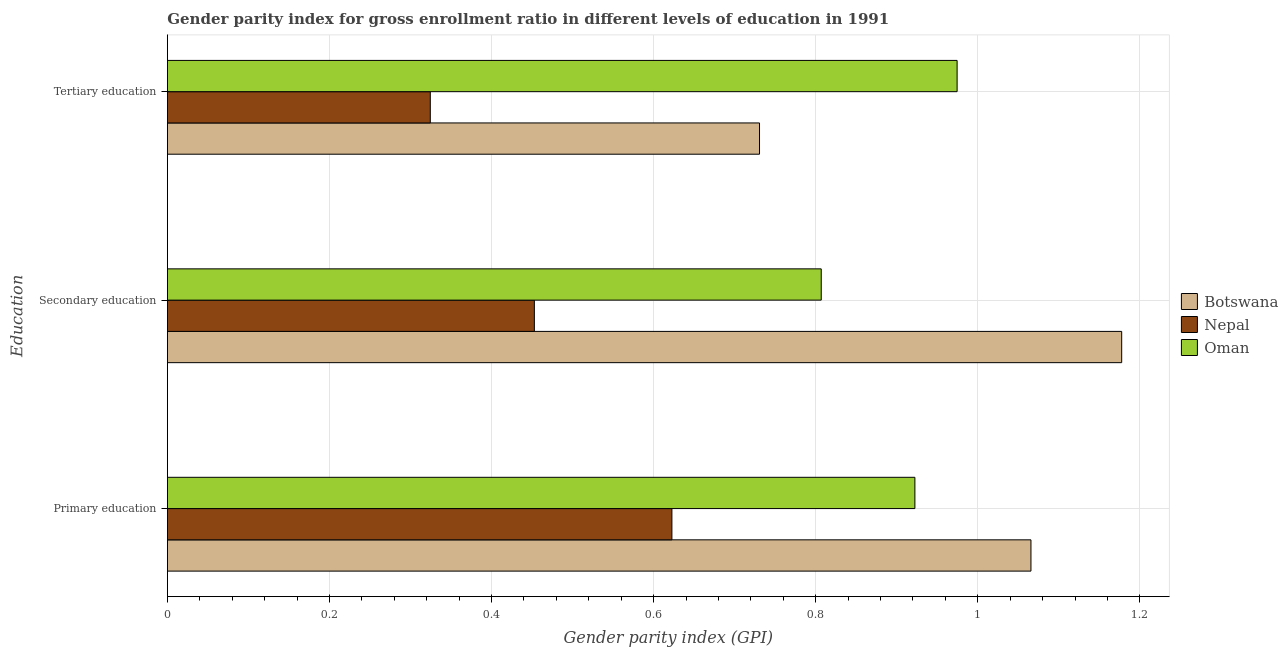Are the number of bars on each tick of the Y-axis equal?
Make the answer very short. Yes. How many bars are there on the 3rd tick from the top?
Ensure brevity in your answer.  3. How many bars are there on the 2nd tick from the bottom?
Provide a short and direct response. 3. What is the label of the 2nd group of bars from the top?
Your answer should be very brief. Secondary education. What is the gender parity index in secondary education in Botswana?
Your response must be concise. 1.18. Across all countries, what is the maximum gender parity index in primary education?
Your answer should be compact. 1.07. Across all countries, what is the minimum gender parity index in primary education?
Provide a short and direct response. 0.62. In which country was the gender parity index in secondary education maximum?
Give a very brief answer. Botswana. In which country was the gender parity index in primary education minimum?
Your answer should be compact. Nepal. What is the total gender parity index in secondary education in the graph?
Ensure brevity in your answer.  2.44. What is the difference between the gender parity index in tertiary education in Nepal and that in Oman?
Provide a succinct answer. -0.65. What is the difference between the gender parity index in secondary education in Nepal and the gender parity index in tertiary education in Oman?
Provide a succinct answer. -0.52. What is the average gender parity index in primary education per country?
Make the answer very short. 0.87. What is the difference between the gender parity index in primary education and gender parity index in secondary education in Oman?
Give a very brief answer. 0.12. In how many countries, is the gender parity index in primary education greater than 1.08 ?
Provide a short and direct response. 0. What is the ratio of the gender parity index in secondary education in Nepal to that in Oman?
Offer a very short reply. 0.56. Is the gender parity index in tertiary education in Oman less than that in Botswana?
Provide a short and direct response. No. What is the difference between the highest and the second highest gender parity index in primary education?
Make the answer very short. 0.14. What is the difference between the highest and the lowest gender parity index in primary education?
Provide a short and direct response. 0.44. Is the sum of the gender parity index in secondary education in Nepal and Oman greater than the maximum gender parity index in primary education across all countries?
Provide a short and direct response. Yes. What does the 2nd bar from the top in Primary education represents?
Give a very brief answer. Nepal. What does the 2nd bar from the bottom in Tertiary education represents?
Give a very brief answer. Nepal. Are all the bars in the graph horizontal?
Provide a short and direct response. Yes. What is the difference between two consecutive major ticks on the X-axis?
Provide a short and direct response. 0.2. Where does the legend appear in the graph?
Make the answer very short. Center right. How many legend labels are there?
Your response must be concise. 3. How are the legend labels stacked?
Your answer should be very brief. Vertical. What is the title of the graph?
Keep it short and to the point. Gender parity index for gross enrollment ratio in different levels of education in 1991. Does "Luxembourg" appear as one of the legend labels in the graph?
Make the answer very short. No. What is the label or title of the X-axis?
Ensure brevity in your answer.  Gender parity index (GPI). What is the label or title of the Y-axis?
Provide a short and direct response. Education. What is the Gender parity index (GPI) of Botswana in Primary education?
Your answer should be compact. 1.07. What is the Gender parity index (GPI) in Nepal in Primary education?
Ensure brevity in your answer.  0.62. What is the Gender parity index (GPI) in Oman in Primary education?
Give a very brief answer. 0.92. What is the Gender parity index (GPI) of Botswana in Secondary education?
Offer a terse response. 1.18. What is the Gender parity index (GPI) of Nepal in Secondary education?
Your answer should be compact. 0.45. What is the Gender parity index (GPI) of Oman in Secondary education?
Your response must be concise. 0.81. What is the Gender parity index (GPI) of Botswana in Tertiary education?
Offer a terse response. 0.73. What is the Gender parity index (GPI) of Nepal in Tertiary education?
Give a very brief answer. 0.32. What is the Gender parity index (GPI) in Oman in Tertiary education?
Provide a short and direct response. 0.97. Across all Education, what is the maximum Gender parity index (GPI) in Botswana?
Provide a succinct answer. 1.18. Across all Education, what is the maximum Gender parity index (GPI) in Nepal?
Offer a terse response. 0.62. Across all Education, what is the maximum Gender parity index (GPI) in Oman?
Keep it short and to the point. 0.97. Across all Education, what is the minimum Gender parity index (GPI) of Botswana?
Keep it short and to the point. 0.73. Across all Education, what is the minimum Gender parity index (GPI) of Nepal?
Your answer should be compact. 0.32. Across all Education, what is the minimum Gender parity index (GPI) in Oman?
Keep it short and to the point. 0.81. What is the total Gender parity index (GPI) in Botswana in the graph?
Your response must be concise. 2.97. What is the total Gender parity index (GPI) of Nepal in the graph?
Keep it short and to the point. 1.4. What is the total Gender parity index (GPI) of Oman in the graph?
Provide a succinct answer. 2.7. What is the difference between the Gender parity index (GPI) of Botswana in Primary education and that in Secondary education?
Offer a terse response. -0.11. What is the difference between the Gender parity index (GPI) of Nepal in Primary education and that in Secondary education?
Offer a terse response. 0.17. What is the difference between the Gender parity index (GPI) in Oman in Primary education and that in Secondary education?
Your answer should be compact. 0.12. What is the difference between the Gender parity index (GPI) in Botswana in Primary education and that in Tertiary education?
Provide a succinct answer. 0.33. What is the difference between the Gender parity index (GPI) of Nepal in Primary education and that in Tertiary education?
Provide a succinct answer. 0.3. What is the difference between the Gender parity index (GPI) in Oman in Primary education and that in Tertiary education?
Your answer should be very brief. -0.05. What is the difference between the Gender parity index (GPI) of Botswana in Secondary education and that in Tertiary education?
Your answer should be compact. 0.45. What is the difference between the Gender parity index (GPI) of Nepal in Secondary education and that in Tertiary education?
Make the answer very short. 0.13. What is the difference between the Gender parity index (GPI) of Oman in Secondary education and that in Tertiary education?
Your answer should be very brief. -0.17. What is the difference between the Gender parity index (GPI) in Botswana in Primary education and the Gender parity index (GPI) in Nepal in Secondary education?
Your answer should be compact. 0.61. What is the difference between the Gender parity index (GPI) of Botswana in Primary education and the Gender parity index (GPI) of Oman in Secondary education?
Your answer should be very brief. 0.26. What is the difference between the Gender parity index (GPI) in Nepal in Primary education and the Gender parity index (GPI) in Oman in Secondary education?
Offer a very short reply. -0.18. What is the difference between the Gender parity index (GPI) in Botswana in Primary education and the Gender parity index (GPI) in Nepal in Tertiary education?
Your answer should be compact. 0.74. What is the difference between the Gender parity index (GPI) of Botswana in Primary education and the Gender parity index (GPI) of Oman in Tertiary education?
Provide a succinct answer. 0.09. What is the difference between the Gender parity index (GPI) of Nepal in Primary education and the Gender parity index (GPI) of Oman in Tertiary education?
Give a very brief answer. -0.35. What is the difference between the Gender parity index (GPI) in Botswana in Secondary education and the Gender parity index (GPI) in Nepal in Tertiary education?
Your answer should be very brief. 0.85. What is the difference between the Gender parity index (GPI) of Botswana in Secondary education and the Gender parity index (GPI) of Oman in Tertiary education?
Provide a short and direct response. 0.2. What is the difference between the Gender parity index (GPI) of Nepal in Secondary education and the Gender parity index (GPI) of Oman in Tertiary education?
Offer a terse response. -0.52. What is the average Gender parity index (GPI) in Nepal per Education?
Give a very brief answer. 0.47. What is the average Gender parity index (GPI) in Oman per Education?
Provide a short and direct response. 0.9. What is the difference between the Gender parity index (GPI) of Botswana and Gender parity index (GPI) of Nepal in Primary education?
Provide a short and direct response. 0.44. What is the difference between the Gender parity index (GPI) in Botswana and Gender parity index (GPI) in Oman in Primary education?
Make the answer very short. 0.14. What is the difference between the Gender parity index (GPI) of Nepal and Gender parity index (GPI) of Oman in Primary education?
Your response must be concise. -0.3. What is the difference between the Gender parity index (GPI) in Botswana and Gender parity index (GPI) in Nepal in Secondary education?
Make the answer very short. 0.72. What is the difference between the Gender parity index (GPI) in Botswana and Gender parity index (GPI) in Oman in Secondary education?
Your response must be concise. 0.37. What is the difference between the Gender parity index (GPI) of Nepal and Gender parity index (GPI) of Oman in Secondary education?
Offer a very short reply. -0.35. What is the difference between the Gender parity index (GPI) in Botswana and Gender parity index (GPI) in Nepal in Tertiary education?
Give a very brief answer. 0.41. What is the difference between the Gender parity index (GPI) of Botswana and Gender parity index (GPI) of Oman in Tertiary education?
Make the answer very short. -0.24. What is the difference between the Gender parity index (GPI) in Nepal and Gender parity index (GPI) in Oman in Tertiary education?
Offer a very short reply. -0.65. What is the ratio of the Gender parity index (GPI) of Botswana in Primary education to that in Secondary education?
Offer a very short reply. 0.9. What is the ratio of the Gender parity index (GPI) in Nepal in Primary education to that in Secondary education?
Your answer should be very brief. 1.37. What is the ratio of the Gender parity index (GPI) of Oman in Primary education to that in Secondary education?
Keep it short and to the point. 1.14. What is the ratio of the Gender parity index (GPI) of Botswana in Primary education to that in Tertiary education?
Your answer should be compact. 1.46. What is the ratio of the Gender parity index (GPI) of Nepal in Primary education to that in Tertiary education?
Your response must be concise. 1.92. What is the ratio of the Gender parity index (GPI) in Oman in Primary education to that in Tertiary education?
Your answer should be very brief. 0.95. What is the ratio of the Gender parity index (GPI) of Botswana in Secondary education to that in Tertiary education?
Provide a succinct answer. 1.61. What is the ratio of the Gender parity index (GPI) in Nepal in Secondary education to that in Tertiary education?
Offer a very short reply. 1.4. What is the ratio of the Gender parity index (GPI) of Oman in Secondary education to that in Tertiary education?
Your answer should be compact. 0.83. What is the difference between the highest and the second highest Gender parity index (GPI) in Botswana?
Provide a short and direct response. 0.11. What is the difference between the highest and the second highest Gender parity index (GPI) in Nepal?
Give a very brief answer. 0.17. What is the difference between the highest and the second highest Gender parity index (GPI) of Oman?
Your answer should be very brief. 0.05. What is the difference between the highest and the lowest Gender parity index (GPI) of Botswana?
Offer a terse response. 0.45. What is the difference between the highest and the lowest Gender parity index (GPI) in Nepal?
Provide a short and direct response. 0.3. What is the difference between the highest and the lowest Gender parity index (GPI) of Oman?
Offer a terse response. 0.17. 